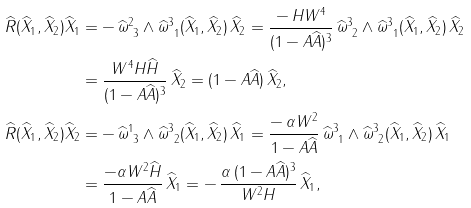<formula> <loc_0><loc_0><loc_500><loc_500>\widehat { R } ( \widehat { X } _ { 1 } , \widehat { X } _ { 2 } ) \widehat { X } _ { 1 } & = - \, \widehat { \omega } ^ { 2 } _ { \ 3 } \wedge \widehat { \omega } ^ { 3 } _ { \ 1 } ( \widehat { X } _ { 1 } , \widehat { X } _ { 2 } ) \, \widehat { X } _ { 2 } = \frac { - \, H W ^ { 4 } } { ( 1 - A \widehat { A } ) ^ { 3 } } \, \widehat { \omega } ^ { 3 } _ { \ 2 } \wedge \widehat { \omega } ^ { 3 } _ { \ 1 } ( \widehat { X } _ { 1 } , \widehat { X } _ { 2 } ) \, \widehat { X } _ { 2 } \\ & = \frac { W ^ { 4 } H \widehat { H } } { ( 1 - A \widehat { A } ) ^ { 3 } } \, \widehat { X } _ { 2 } = ( 1 - A \widehat { A } ) \, \widehat { X } _ { 2 } , \\ \widehat { R } ( \widehat { X } _ { 1 } , \widehat { X } _ { 2 } ) \widehat { X } _ { 2 } & = - \, \widehat { \omega } ^ { 1 } _ { \ 3 } \wedge \widehat { \omega } ^ { 3 } _ { \ 2 } ( \widehat { X } _ { 1 } , \widehat { X } _ { 2 } ) \, \widehat { X } _ { 1 } = \frac { - \, \alpha W ^ { 2 } } { 1 - A \widehat { A } } \, \widehat { \omega } ^ { 3 } _ { \ 1 } \wedge \widehat { \omega } ^ { 3 } _ { \ 2 } ( \widehat { X } _ { 1 } , \widehat { X } _ { 2 } ) \, \widehat { X } _ { 1 } \\ & = \frac { - \alpha W ^ { 2 } \widehat { H } } { 1 - A \widehat { A } } \, \widehat { X } _ { 1 } = - \, \frac { \alpha \, ( 1 - A \widehat { A } ) ^ { 3 } } { W ^ { 2 } H } \, \widehat { X } _ { 1 } ,</formula> 